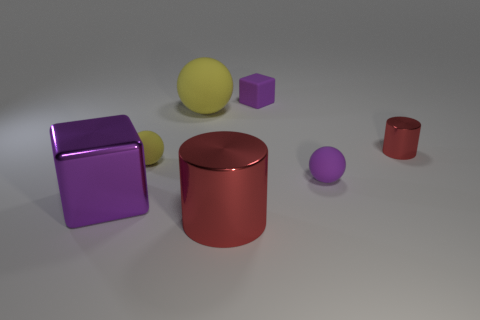Add 1 big purple objects. How many objects exist? 8 Subtract all cylinders. How many objects are left? 5 Add 3 tiny purple spheres. How many tiny purple spheres exist? 4 Subtract 1 purple spheres. How many objects are left? 6 Subtract all big purple metal things. Subtract all cylinders. How many objects are left? 4 Add 4 balls. How many balls are left? 7 